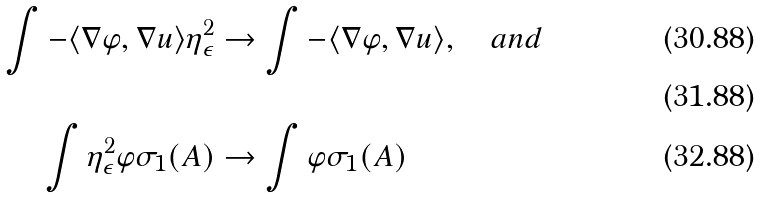Convert formula to latex. <formula><loc_0><loc_0><loc_500><loc_500>\int - \langle \nabla \varphi , \nabla u \rangle \eta _ { \epsilon } ^ { 2 } & \to \int - \langle \nabla \varphi , \nabla u \rangle , \quad a n d \\ \\ \int \eta _ { \epsilon } ^ { 2 } \varphi \sigma _ { 1 } ( A ) & \to \int \varphi \sigma _ { 1 } ( A )</formula> 